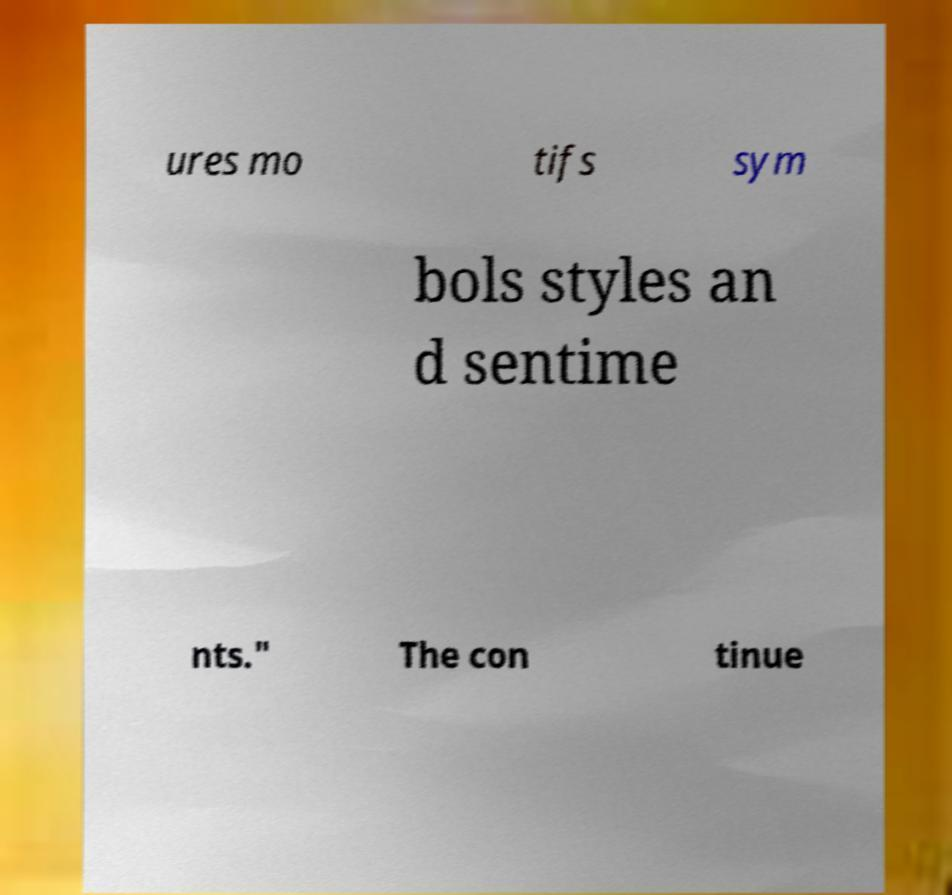What messages or text are displayed in this image? I need them in a readable, typed format. ures mo tifs sym bols styles an d sentime nts." The con tinue 